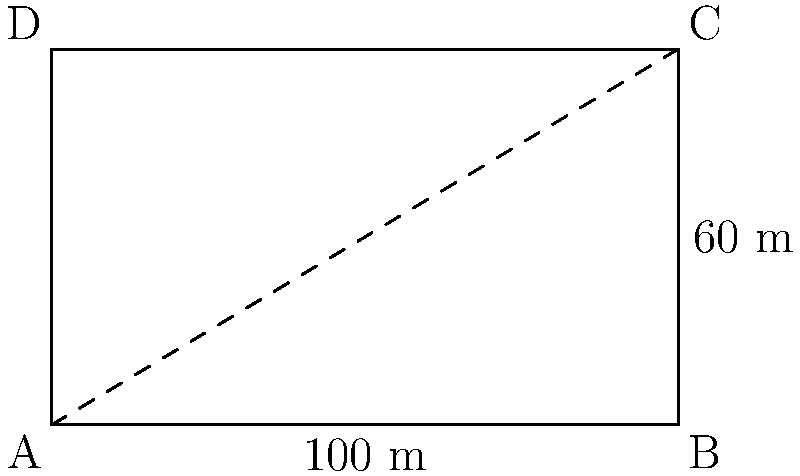In the Al-Wahda Stadium in Sana'a, Yemen, the football field measures 100 meters long and 60 meters wide. If you were to run diagonally from one corner to the opposite corner, what would be the length of your run? Round your answer to the nearest meter. Let's approach this step-by-step:

1) The football field forms a rectangle. The diagonal of this rectangle forms a right triangle with the length and width of the field.

2) We can use the Pythagorean theorem to find the length of the diagonal. Let's call the diagonal $d$.

3) According to the Pythagorean theorem:

   $d^2 = 100^2 + 60^2$

4) Let's calculate:
   $d^2 = 10000 + 3600 = 13600$

5) To find $d$, we need to take the square root of both sides:

   $d = \sqrt{13600}$

6) Using a calculator:

   $d \approx 116.619$ meters

7) Rounding to the nearest meter:

   $d \approx 117$ meters

Alternatively, we could have used trigonometry:

1) The angle $\theta$ is given by $\tan^{-1}(\frac{60}{100}) \approx 30.96°$

2) The diagonal $d$ can then be found using:

   $d = \frac{100}{\cos(30.96°)} \approx 116.619$ meters

This gives the same result as the Pythagorean method.
Answer: 117 meters 